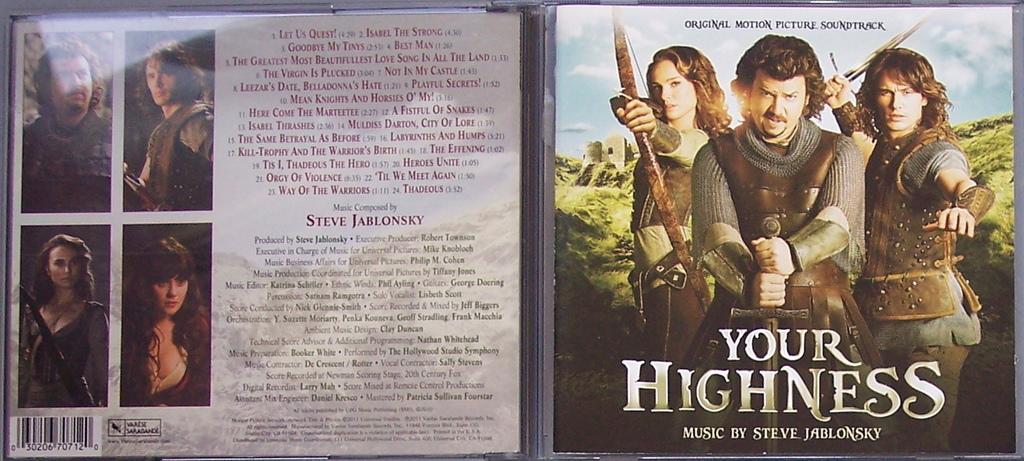What movie does this cd contain the soundtrack to?
Make the answer very short. Your highness. Who created the music?
Ensure brevity in your answer.  Steve jablonsky. 